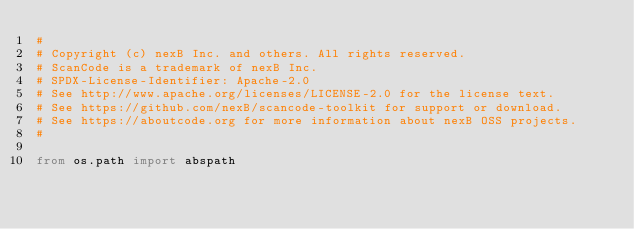Convert code to text. <code><loc_0><loc_0><loc_500><loc_500><_Python_>#
# Copyright (c) nexB Inc. and others. All rights reserved.
# ScanCode is a trademark of nexB Inc.
# SPDX-License-Identifier: Apache-2.0
# See http://www.apache.org/licenses/LICENSE-2.0 for the license text.
# See https://github.com/nexB/scancode-toolkit for support or download.
# See https://aboutcode.org for more information about nexB OSS projects.
#

from os.path import abspath</code> 